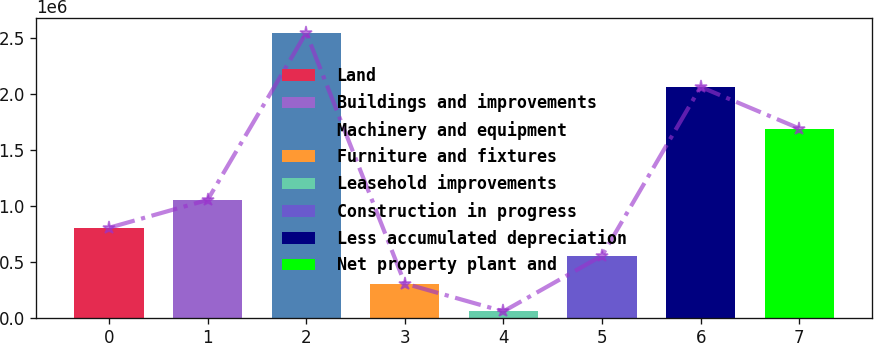<chart> <loc_0><loc_0><loc_500><loc_500><bar_chart><fcel>Land<fcel>Buildings and improvements<fcel>Machinery and equipment<fcel>Furniture and fixtures<fcel>Leasehold improvements<fcel>Construction in progress<fcel>Less accumulated depreciation<fcel>Net property plant and<nl><fcel>803650<fcel>1.05324e+06<fcel>2.55078e+06<fcel>304470<fcel>54880<fcel>554060<fcel>2.06547e+06<fcel>1.69285e+06<nl></chart> 